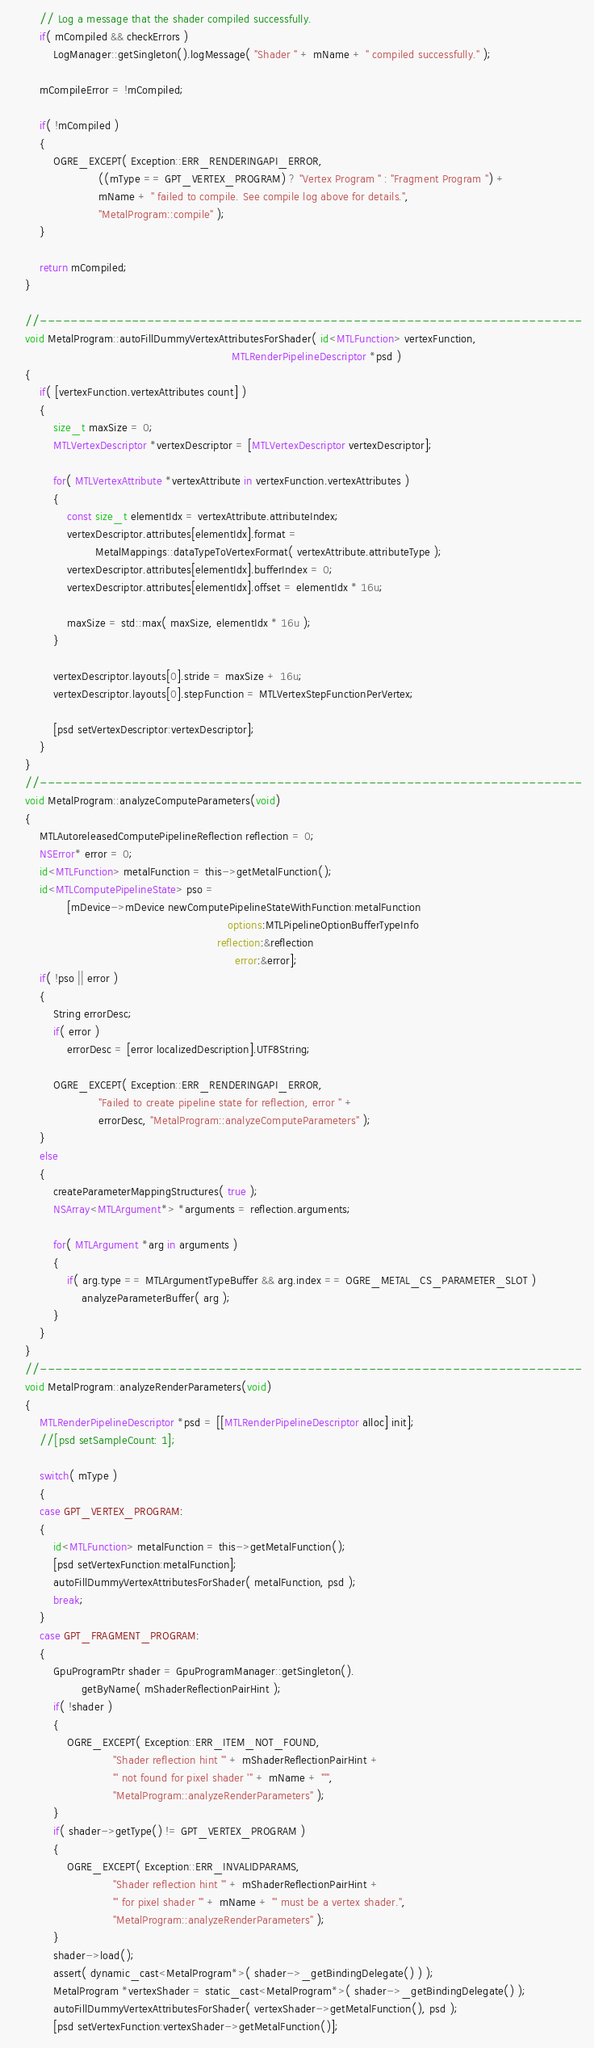<code> <loc_0><loc_0><loc_500><loc_500><_ObjectiveC_>        // Log a message that the shader compiled successfully.
        if( mCompiled && checkErrors )
            LogManager::getSingleton().logMessage( "Shader " + mName + " compiled successfully." );

        mCompileError = !mCompiled;

        if( !mCompiled )
        {
            OGRE_EXCEPT( Exception::ERR_RENDERINGAPI_ERROR,
                         ((mType == GPT_VERTEX_PROGRAM) ? "Vertex Program " : "Fragment Program ") +
                         mName + " failed to compile. See compile log above for details.",
                         "MetalProgram::compile" );
        }

        return mCompiled;
    }

    //-----------------------------------------------------------------------
    void MetalProgram::autoFillDummyVertexAttributesForShader( id<MTLFunction> vertexFunction,
                                                               MTLRenderPipelineDescriptor *psd )
    {
        if( [vertexFunction.vertexAttributes count] )
        {
            size_t maxSize = 0;
            MTLVertexDescriptor *vertexDescriptor = [MTLVertexDescriptor vertexDescriptor];

            for( MTLVertexAttribute *vertexAttribute in vertexFunction.vertexAttributes )
            {
                const size_t elementIdx = vertexAttribute.attributeIndex;
                vertexDescriptor.attributes[elementIdx].format =
                        MetalMappings::dataTypeToVertexFormat( vertexAttribute.attributeType );
                vertexDescriptor.attributes[elementIdx].bufferIndex = 0;
                vertexDescriptor.attributes[elementIdx].offset = elementIdx * 16u;

                maxSize = std::max( maxSize, elementIdx * 16u );
            }

            vertexDescriptor.layouts[0].stride = maxSize + 16u;
            vertexDescriptor.layouts[0].stepFunction = MTLVertexStepFunctionPerVertex;

            [psd setVertexDescriptor:vertexDescriptor];
        }
    }
    //-----------------------------------------------------------------------
    void MetalProgram::analyzeComputeParameters(void)
    {
        MTLAutoreleasedComputePipelineReflection reflection = 0;
        NSError* error = 0;
        id<MTLFunction> metalFunction = this->getMetalFunction();
        id<MTLComputePipelineState> pso =
                [mDevice->mDevice newComputePipelineStateWithFunction:metalFunction
                                                              options:MTLPipelineOptionBufferTypeInfo
                                                           reflection:&reflection
                                                                error:&error];
        if( !pso || error )
        {
            String errorDesc;
            if( error )
                errorDesc = [error localizedDescription].UTF8String;

            OGRE_EXCEPT( Exception::ERR_RENDERINGAPI_ERROR,
                         "Failed to create pipeline state for reflection, error " +
                         errorDesc, "MetalProgram::analyzeComputeParameters" );
        }
        else
        {
            createParameterMappingStructures( true );
            NSArray<MTLArgument*> *arguments = reflection.arguments;

            for( MTLArgument *arg in arguments )
            {
                if( arg.type == MTLArgumentTypeBuffer && arg.index == OGRE_METAL_CS_PARAMETER_SLOT )
                    analyzeParameterBuffer( arg );
            }
        }
    }
    //-----------------------------------------------------------------------
    void MetalProgram::analyzeRenderParameters(void)
    {
        MTLRenderPipelineDescriptor *psd = [[MTLRenderPipelineDescriptor alloc] init];
        //[psd setSampleCount: 1];

        switch( mType )
        {
        case GPT_VERTEX_PROGRAM:
        {
            id<MTLFunction> metalFunction = this->getMetalFunction();
            [psd setVertexFunction:metalFunction];
            autoFillDummyVertexAttributesForShader( metalFunction, psd );
            break;
        }
        case GPT_FRAGMENT_PROGRAM:
        {
            GpuProgramPtr shader = GpuProgramManager::getSingleton().
                    getByName( mShaderReflectionPairHint );
            if( !shader )
            {
                OGRE_EXCEPT( Exception::ERR_ITEM_NOT_FOUND,
                             "Shader reflection hint '" + mShaderReflectionPairHint +
                             "' not found for pixel shader '" + mName + "'",
                             "MetalProgram::analyzeRenderParameters" );
            }
            if( shader->getType() != GPT_VERTEX_PROGRAM )
            {
                OGRE_EXCEPT( Exception::ERR_INVALIDPARAMS,
                             "Shader reflection hint '" + mShaderReflectionPairHint +
                             "' for pixel shader '" + mName + "' must be a vertex shader.",
                             "MetalProgram::analyzeRenderParameters" );
            }
            shader->load();
            assert( dynamic_cast<MetalProgram*>( shader->_getBindingDelegate() ) );
            MetalProgram *vertexShader = static_cast<MetalProgram*>( shader->_getBindingDelegate() );
            autoFillDummyVertexAttributesForShader( vertexShader->getMetalFunction(), psd );
            [psd setVertexFunction:vertexShader->getMetalFunction()];</code> 